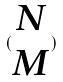Convert formula to latex. <formula><loc_0><loc_0><loc_500><loc_500>( \begin{matrix} N \\ M \end{matrix} )</formula> 